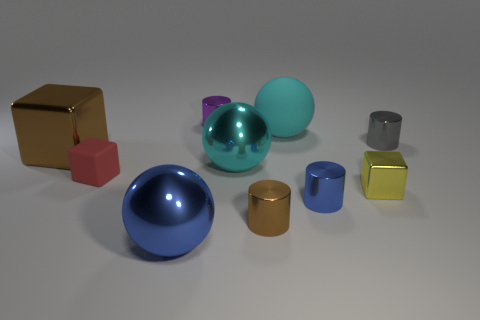Subtract all blocks. How many objects are left? 7 Subtract 1 red blocks. How many objects are left? 9 Subtract all gray cylinders. Subtract all cyan things. How many objects are left? 7 Add 4 tiny purple objects. How many tiny purple objects are left? 5 Add 6 gray shiny things. How many gray shiny things exist? 7 